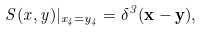<formula> <loc_0><loc_0><loc_500><loc_500>S ( x , y ) | _ { x _ { 4 } = y _ { 4 } } = \delta ^ { 3 } ( { \mathbf x } - { \mathbf y } ) ,</formula> 